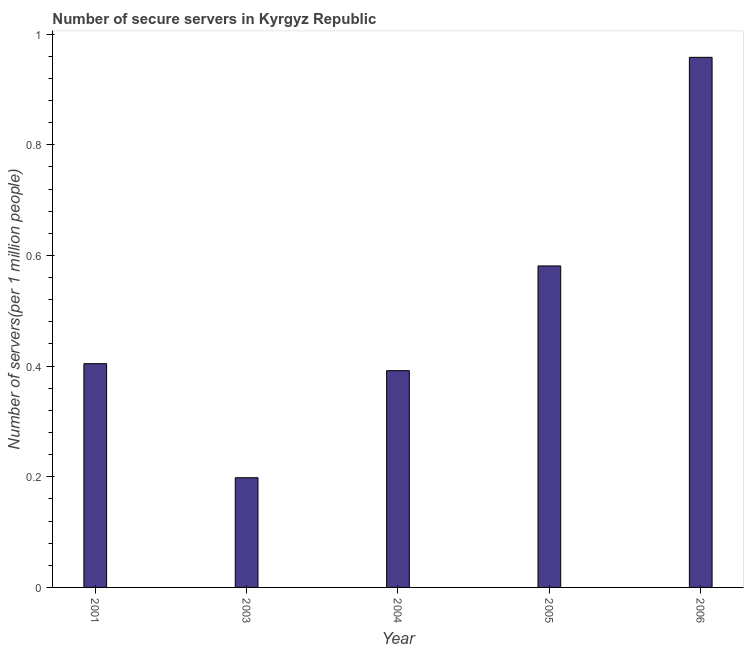What is the title of the graph?
Offer a terse response. Number of secure servers in Kyrgyz Republic. What is the label or title of the X-axis?
Keep it short and to the point. Year. What is the label or title of the Y-axis?
Provide a succinct answer. Number of servers(per 1 million people). What is the number of secure internet servers in 2006?
Your response must be concise. 0.96. Across all years, what is the maximum number of secure internet servers?
Make the answer very short. 0.96. Across all years, what is the minimum number of secure internet servers?
Provide a short and direct response. 0.2. What is the sum of the number of secure internet servers?
Make the answer very short. 2.53. What is the difference between the number of secure internet servers in 2004 and 2006?
Provide a succinct answer. -0.57. What is the average number of secure internet servers per year?
Offer a very short reply. 0.51. What is the median number of secure internet servers?
Offer a very short reply. 0.4. Do a majority of the years between 2003 and 2006 (inclusive) have number of secure internet servers greater than 0.68 ?
Make the answer very short. No. What is the ratio of the number of secure internet servers in 2003 to that in 2005?
Make the answer very short. 0.34. Is the number of secure internet servers in 2001 less than that in 2005?
Give a very brief answer. Yes. Is the difference between the number of secure internet servers in 2004 and 2006 greater than the difference between any two years?
Your response must be concise. No. What is the difference between the highest and the second highest number of secure internet servers?
Make the answer very short. 0.38. What is the difference between the highest and the lowest number of secure internet servers?
Make the answer very short. 0.76. What is the difference between two consecutive major ticks on the Y-axis?
Your response must be concise. 0.2. What is the Number of servers(per 1 million people) of 2001?
Give a very brief answer. 0.4. What is the Number of servers(per 1 million people) in 2003?
Offer a terse response. 0.2. What is the Number of servers(per 1 million people) of 2004?
Make the answer very short. 0.39. What is the Number of servers(per 1 million people) of 2005?
Ensure brevity in your answer.  0.58. What is the Number of servers(per 1 million people) in 2006?
Make the answer very short. 0.96. What is the difference between the Number of servers(per 1 million people) in 2001 and 2003?
Provide a short and direct response. 0.21. What is the difference between the Number of servers(per 1 million people) in 2001 and 2004?
Provide a short and direct response. 0.01. What is the difference between the Number of servers(per 1 million people) in 2001 and 2005?
Provide a short and direct response. -0.18. What is the difference between the Number of servers(per 1 million people) in 2001 and 2006?
Offer a terse response. -0.55. What is the difference between the Number of servers(per 1 million people) in 2003 and 2004?
Your response must be concise. -0.19. What is the difference between the Number of servers(per 1 million people) in 2003 and 2005?
Your response must be concise. -0.38. What is the difference between the Number of servers(per 1 million people) in 2003 and 2006?
Your response must be concise. -0.76. What is the difference between the Number of servers(per 1 million people) in 2004 and 2005?
Your answer should be very brief. -0.19. What is the difference between the Number of servers(per 1 million people) in 2004 and 2006?
Your answer should be very brief. -0.57. What is the difference between the Number of servers(per 1 million people) in 2005 and 2006?
Your response must be concise. -0.38. What is the ratio of the Number of servers(per 1 million people) in 2001 to that in 2003?
Provide a short and direct response. 2.04. What is the ratio of the Number of servers(per 1 million people) in 2001 to that in 2004?
Offer a terse response. 1.03. What is the ratio of the Number of servers(per 1 million people) in 2001 to that in 2005?
Ensure brevity in your answer.  0.7. What is the ratio of the Number of servers(per 1 million people) in 2001 to that in 2006?
Your answer should be compact. 0.42. What is the ratio of the Number of servers(per 1 million people) in 2003 to that in 2004?
Your answer should be compact. 0.51. What is the ratio of the Number of servers(per 1 million people) in 2003 to that in 2005?
Your answer should be very brief. 0.34. What is the ratio of the Number of servers(per 1 million people) in 2003 to that in 2006?
Offer a very short reply. 0.21. What is the ratio of the Number of servers(per 1 million people) in 2004 to that in 2005?
Offer a terse response. 0.67. What is the ratio of the Number of servers(per 1 million people) in 2004 to that in 2006?
Provide a short and direct response. 0.41. What is the ratio of the Number of servers(per 1 million people) in 2005 to that in 2006?
Offer a terse response. 0.61. 